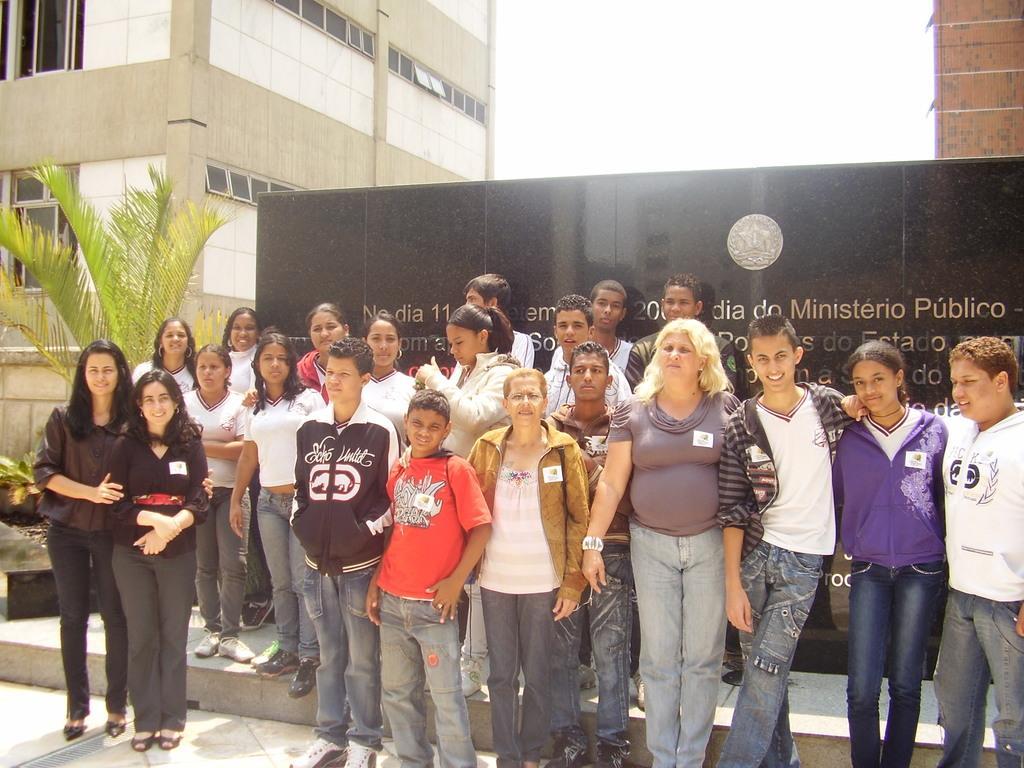Could you give a brief overview of what you see in this image? In front of the picture, we see many people are standing. Behind them, we see a black wall with some text written on it. On the left side, we see a tree. Behind that, we see a building in white and grey color. It has the windows. In the right top of the picture, we see a building or a wall in brown color. At the top of the picture, we see the sky. 